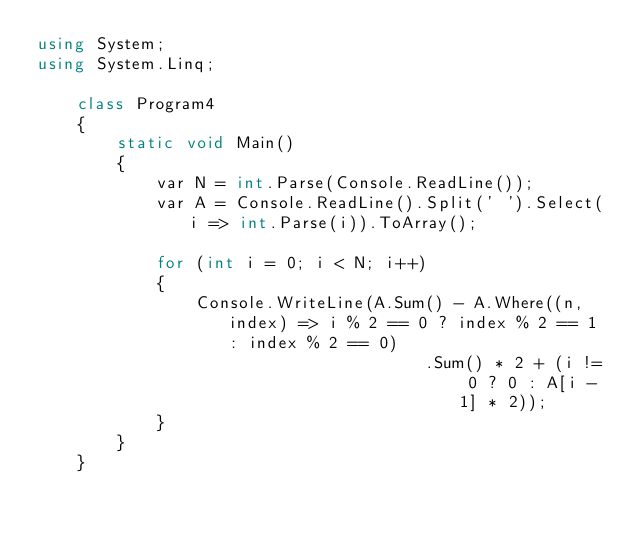Convert code to text. <code><loc_0><loc_0><loc_500><loc_500><_C#_>using System;
using System.Linq;

    class Program4
    {
        static void Main()
        {
            var N = int.Parse(Console.ReadLine());
            var A = Console.ReadLine().Split(' ').Select(i => int.Parse(i)).ToArray();

            for (int i = 0; i < N; i++)
            {
                Console.WriteLine(A.Sum() - A.Where((n, index) => i % 2 == 0 ? index % 2 == 1 : index % 2 == 0)
                                       .Sum() * 2 + (i != 0 ? 0 : A[i - 1] * 2));
            }
        }
    }</code> 